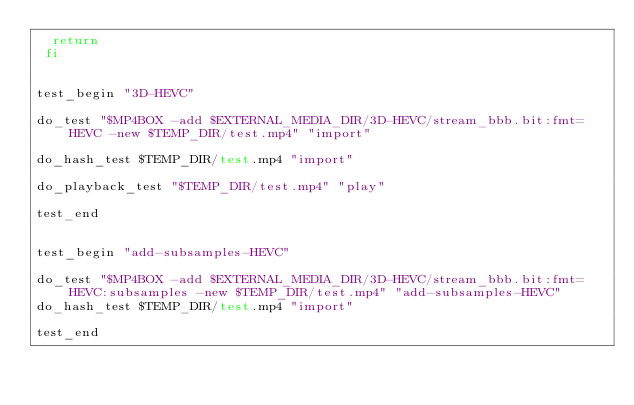Convert code to text. <code><loc_0><loc_0><loc_500><loc_500><_Bash_>  return
 fi


test_begin "3D-HEVC"

do_test "$MP4BOX -add $EXTERNAL_MEDIA_DIR/3D-HEVC/stream_bbb.bit:fmt=HEVC -new $TEMP_DIR/test.mp4" "import"

do_hash_test $TEMP_DIR/test.mp4 "import"

do_playback_test "$TEMP_DIR/test.mp4" "play"

test_end


test_begin "add-subsamples-HEVC"

do_test "$MP4BOX -add $EXTERNAL_MEDIA_DIR/3D-HEVC/stream_bbb.bit:fmt=HEVC:subsamples -new $TEMP_DIR/test.mp4" "add-subsamples-HEVC"
do_hash_test $TEMP_DIR/test.mp4 "import"

test_end
</code> 